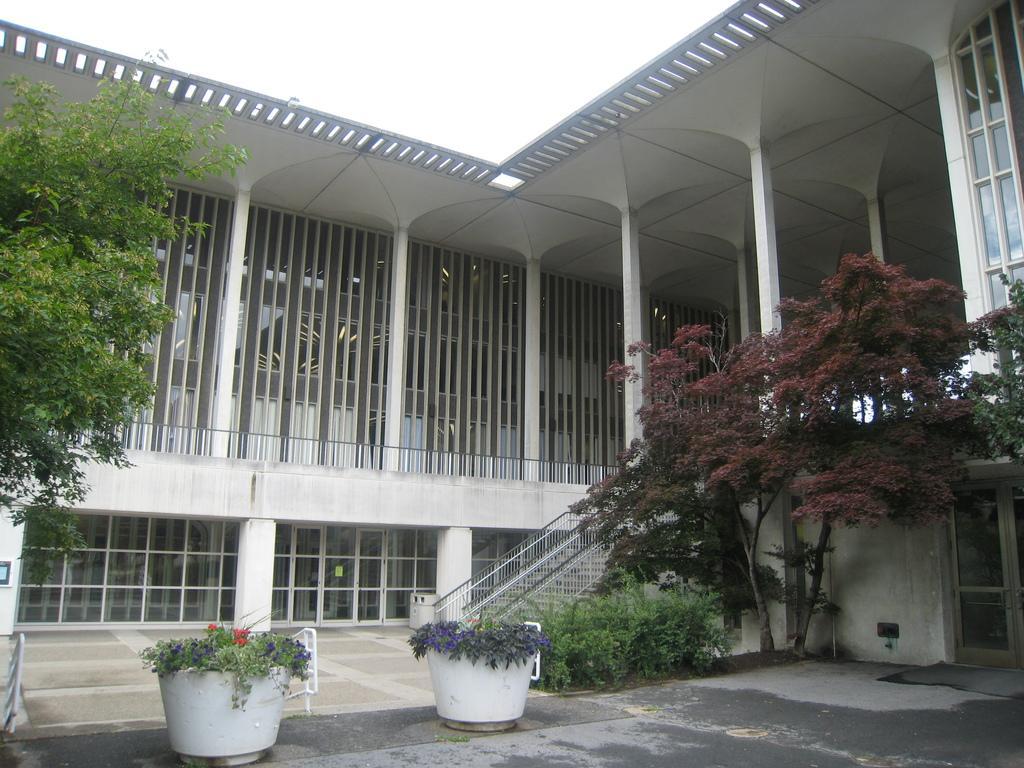Please provide a concise description of this image. In this image we can see the building with stairs, windows, pillars and door. In front of the building we can see the trees and potted plants. At the top we can see the sky. 